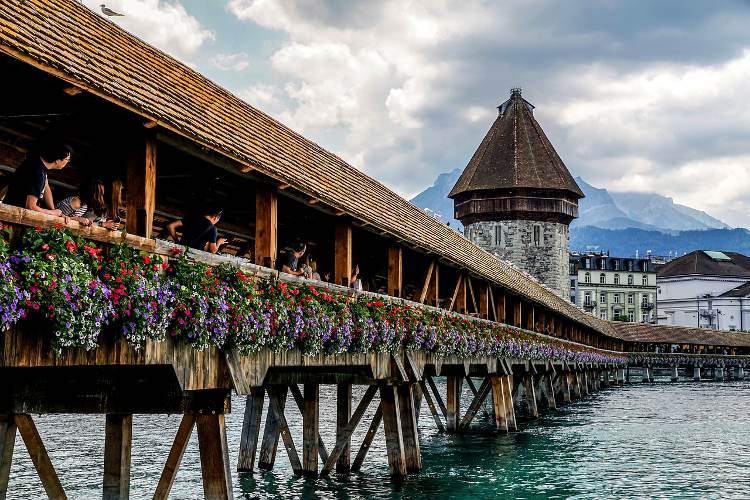I am planning a trip to Lucerne. What else should I not miss? In addition to visiting the Chapel Bridge, there are several other attractions in Lucerne that you should not miss. The Lion Monument, a poignant sculpture commemorating the Swiss Guards who died during the French Revolution, is a must-see. You can also explore the Old Town, with its charming cobblestone streets, historic buildings, and lively markets. The Swiss Transport Museum offers fascinating exhibits on the history of transportation. A boat trip on Lake Lucerne provides stunning views and is a perfect way to enjoy the scenic landscape. For a panoramic view of the city and the Alps, take the funicular to the top of Mount Pilatus or Mount Rigi. Don’t forget to try some traditional Swiss cuisine at local restaurants to complete your trip. 